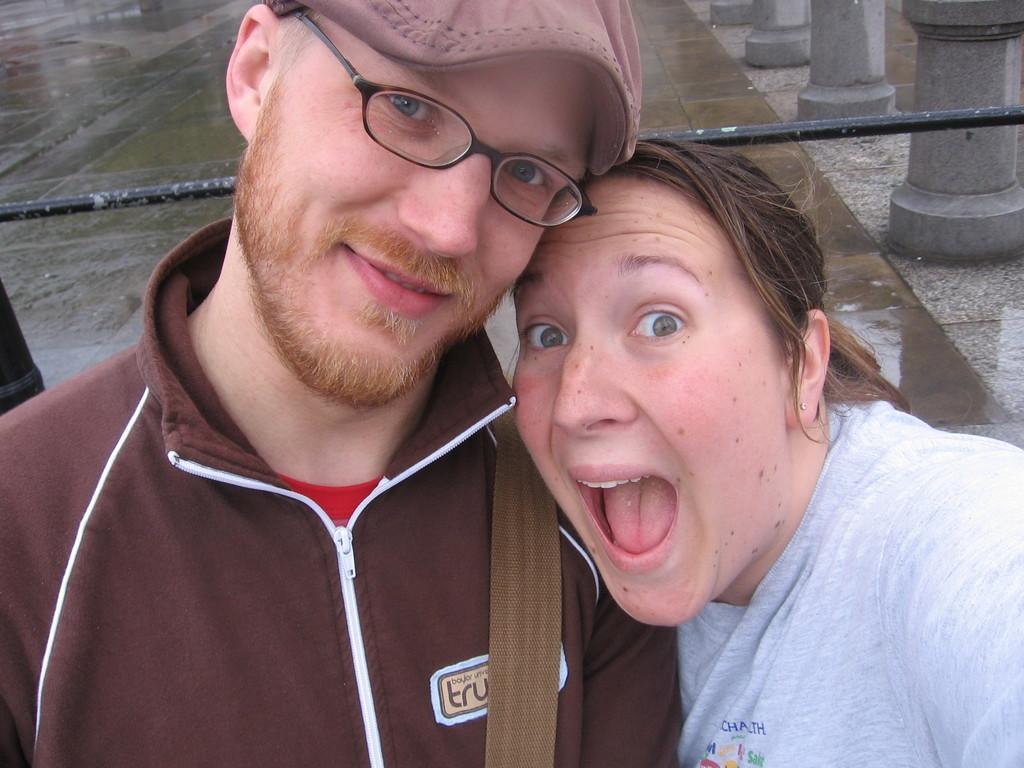How many people are present in the image? There is a man and a woman in the image. What can be seen in the background of the image? Water and pillars are visible in the background of the image. What type of wine is the man drinking in the image? There is no wine present in the image; it only features a man and a woman in the foreground and water and pillars in the background. 